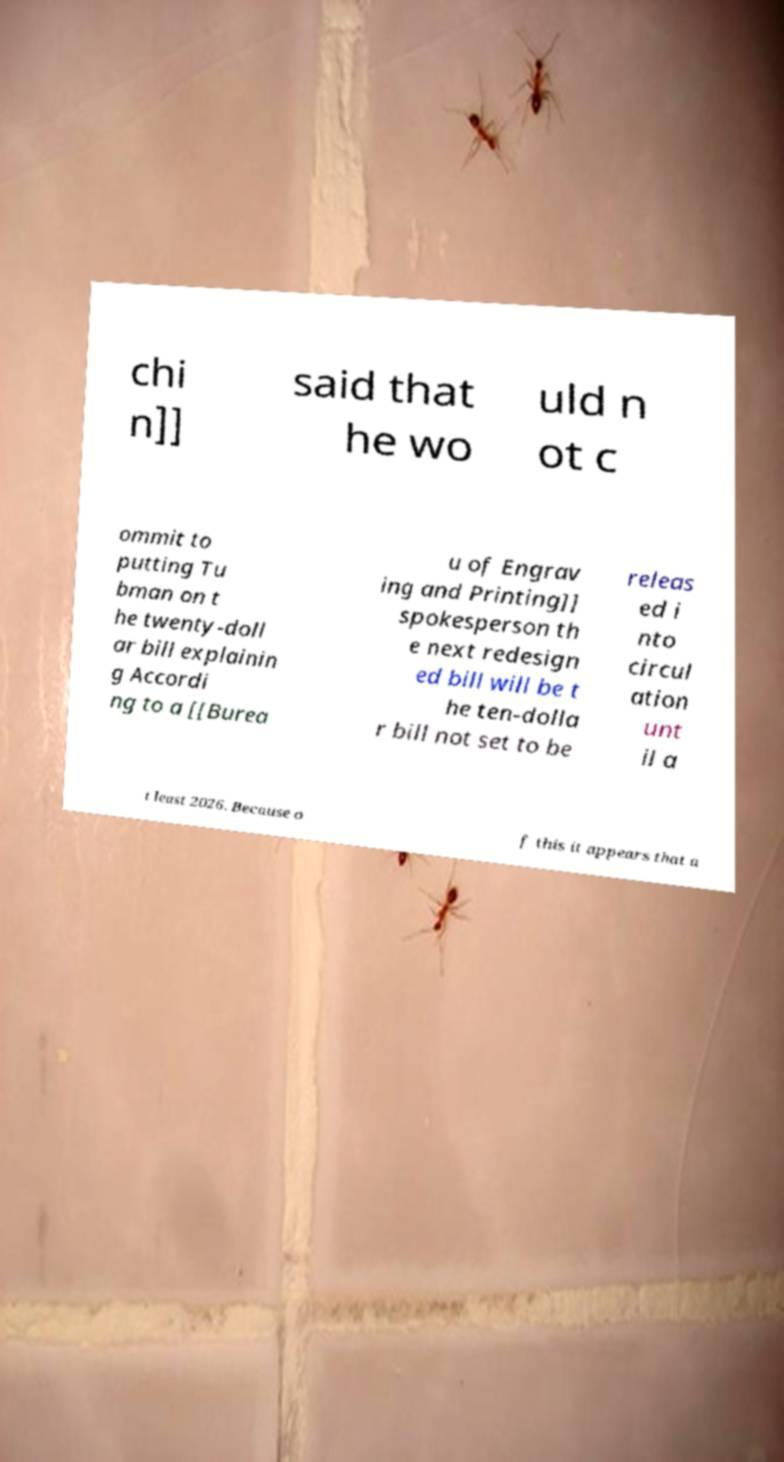Please identify and transcribe the text found in this image. chi n]] said that he wo uld n ot c ommit to putting Tu bman on t he twenty-doll ar bill explainin g Accordi ng to a [[Burea u of Engrav ing and Printing]] spokesperson th e next redesign ed bill will be t he ten-dolla r bill not set to be releas ed i nto circul ation unt il a t least 2026. Because o f this it appears that a 